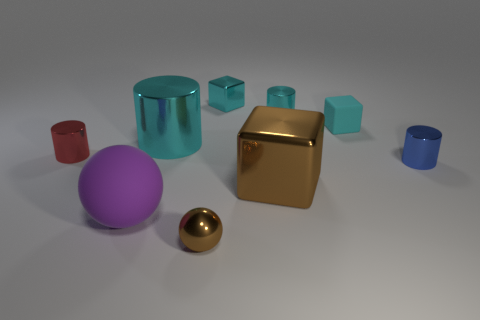There is a thing to the left of the rubber ball; is its shape the same as the purple matte object?
Provide a short and direct response. No. How many things are either purple balls or blocks to the left of the brown cube?
Ensure brevity in your answer.  2. Are there fewer big green metal things than tiny objects?
Your response must be concise. Yes. Is the number of large cyan rubber spheres greater than the number of balls?
Keep it short and to the point. No. How many other objects are there of the same material as the small sphere?
Give a very brief answer. 6. How many small cyan matte things are to the right of the tiny cyan metallic object that is to the right of the brown thing behind the purple sphere?
Offer a terse response. 1. How many rubber objects are small cyan things or blue objects?
Give a very brief answer. 1. There is a metal block that is behind the tiny object that is to the right of the tiny matte thing; how big is it?
Ensure brevity in your answer.  Small. Is the color of the big shiny thing behind the small red shiny object the same as the matte sphere that is in front of the rubber block?
Give a very brief answer. No. What color is the big thing that is both to the left of the tiny metallic ball and in front of the blue shiny cylinder?
Offer a very short reply. Purple. 